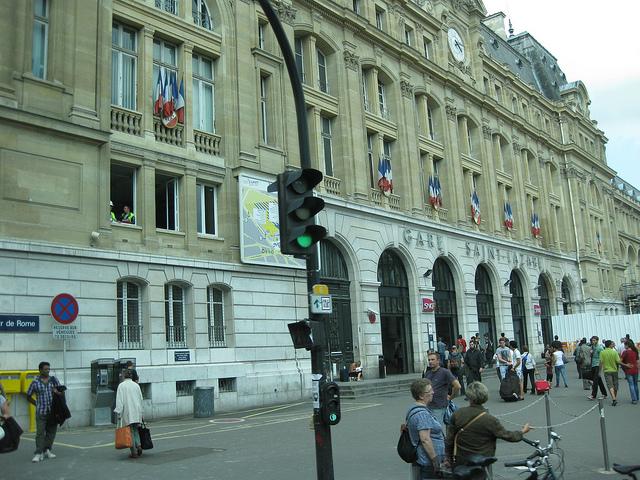How many traffic signals can be seen?
Write a very short answer. 1. Are there windows on the building?
Short answer required. Yes. Is this a beach?
Answer briefly. No. Is this a government building?
Quick response, please. Yes. What color is the light?
Short answer required. Green. Are there any cars visible?
Quick response, please. No. Where is the bell?
Short answer required. Tower. Is there a bus?
Answer briefly. No. 